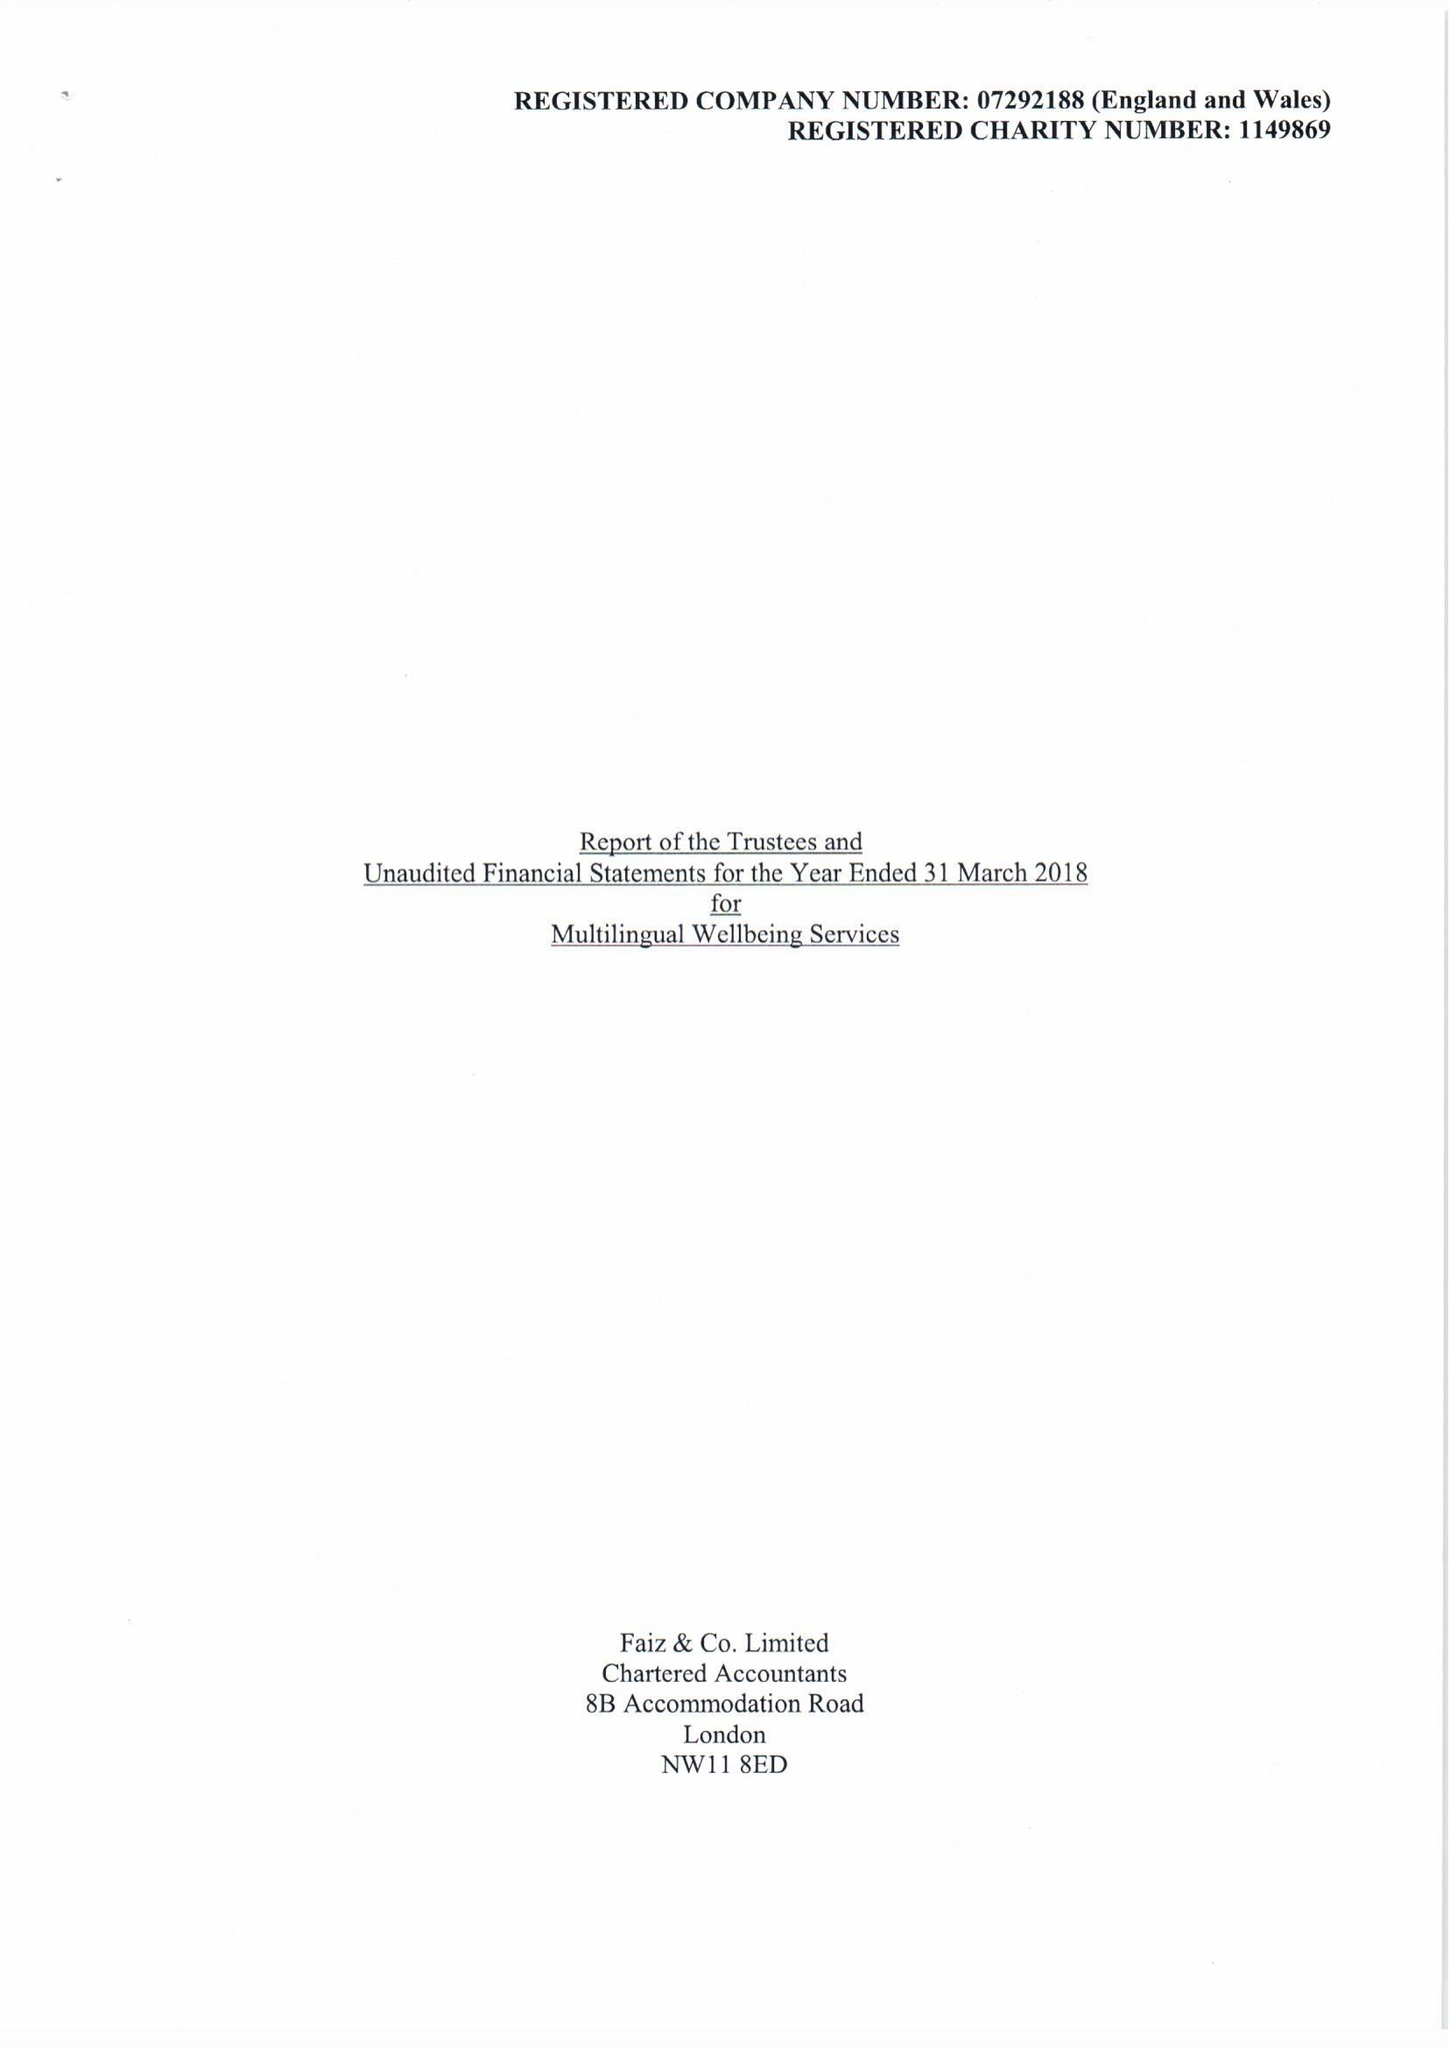What is the value for the charity_name?
Answer the question using a single word or phrase. Multilingual Wellbeing Services 